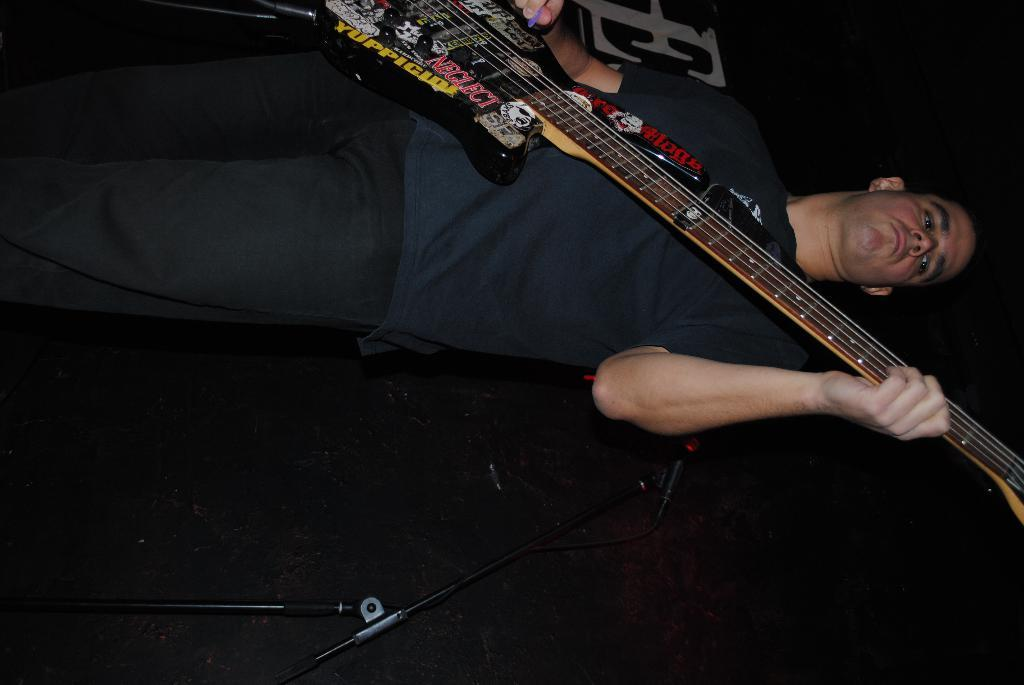What is the man in the image doing? The man is playing a guitar in the image. Can you describe any other objects or equipment in the image? Yes, there is a tripod in the image. What type of leaf can be seen falling from the guitar in the image? There is no leaf or any indication of a leaf falling from the guitar in the image. 